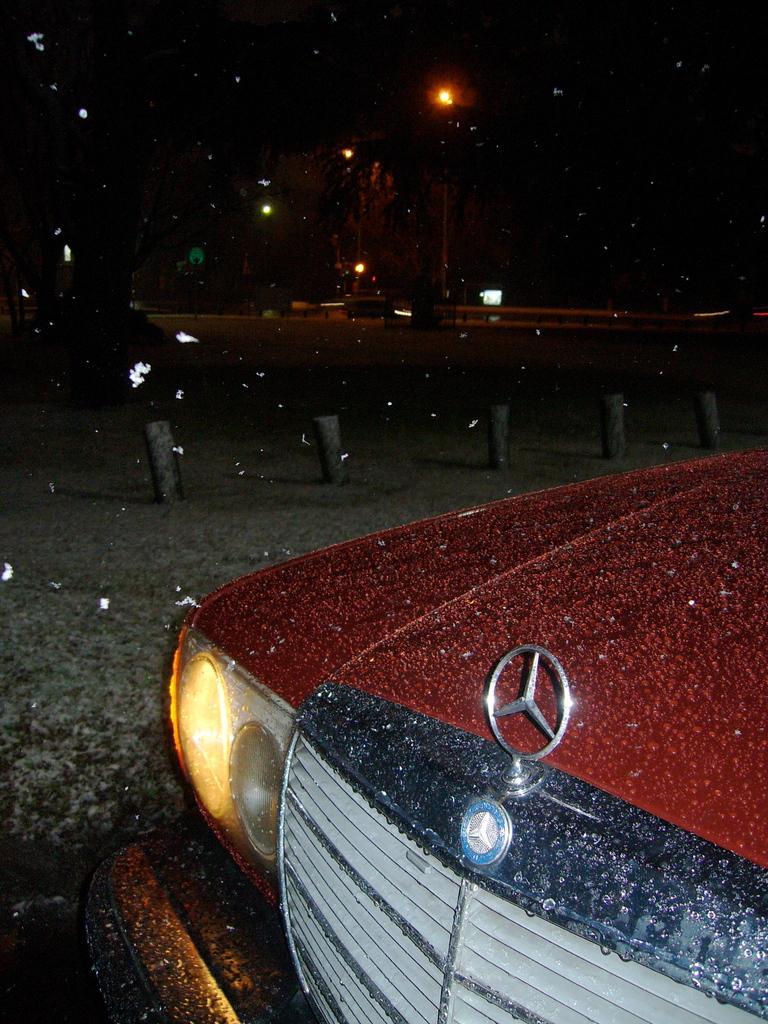Please provide a concise description of this image. In this image I can see the red color car and few light poles. Background is dark in color. 